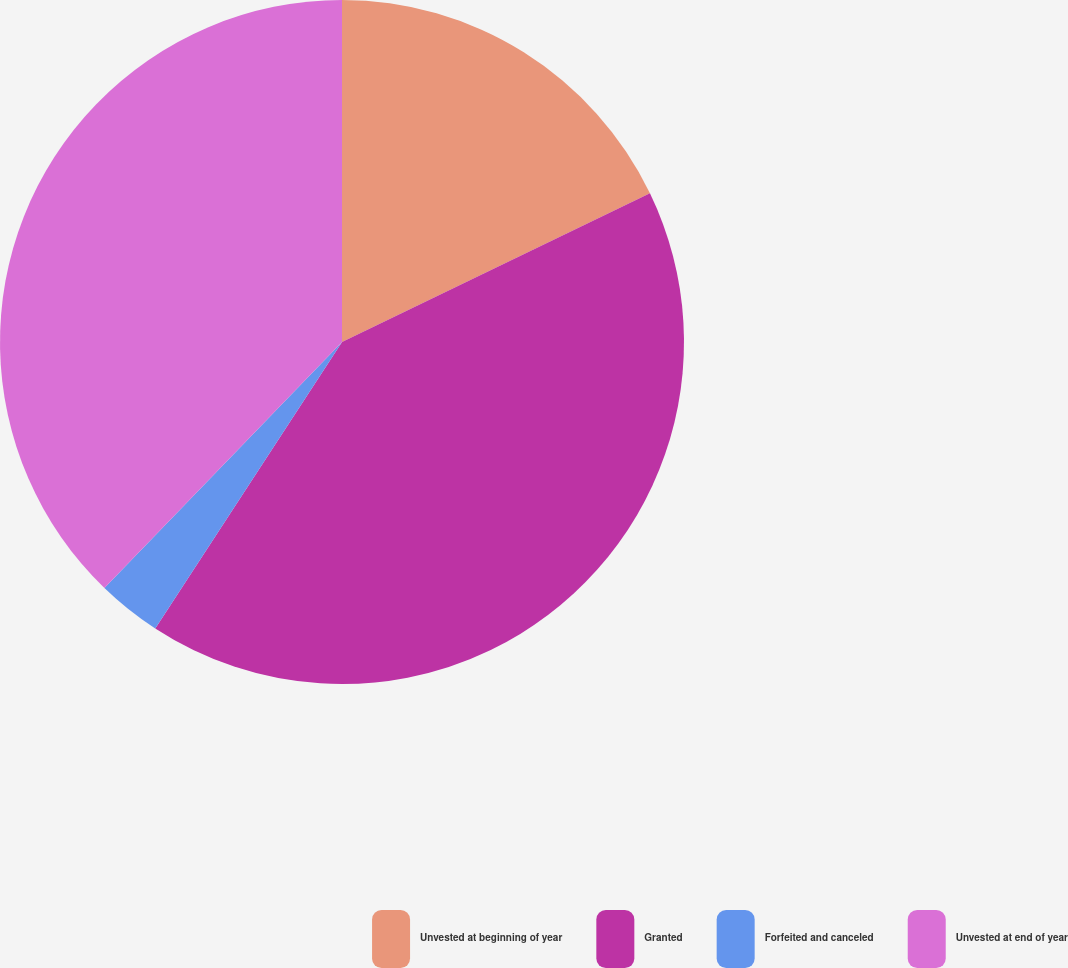<chart> <loc_0><loc_0><loc_500><loc_500><pie_chart><fcel>Unvested at beginning of year<fcel>Granted<fcel>Forfeited and canceled<fcel>Unvested at end of year<nl><fcel>17.84%<fcel>41.36%<fcel>3.03%<fcel>37.78%<nl></chart> 